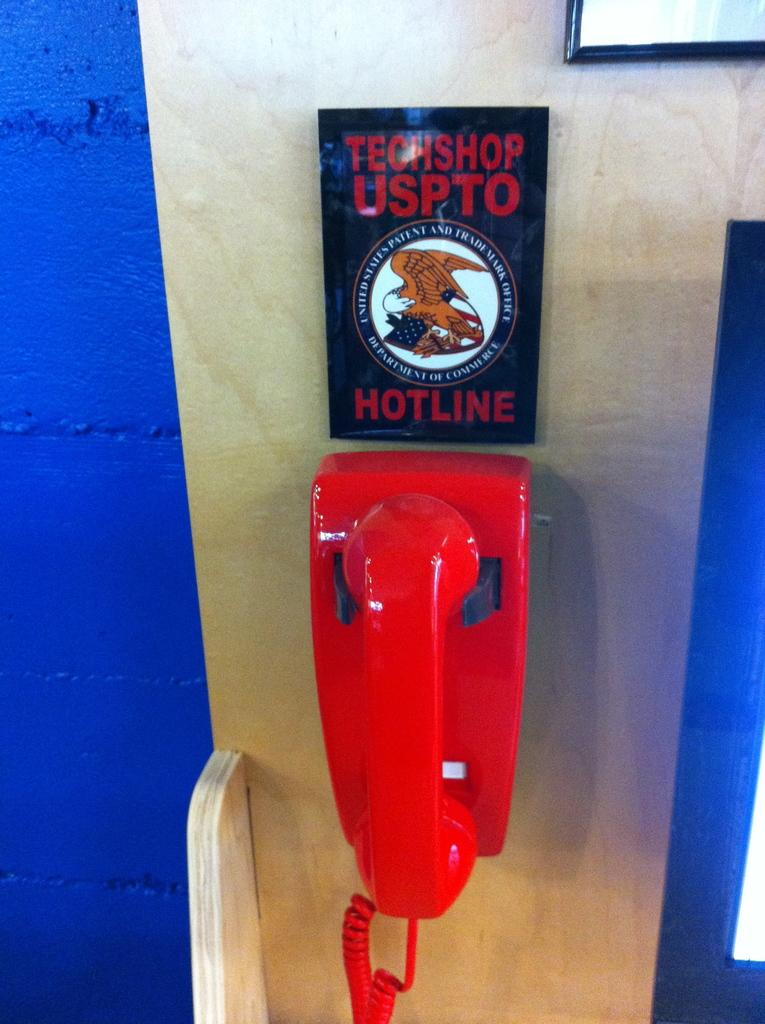<image>
Summarize the visual content of the image. A red wired phone below a sign that says Techshop Uspto Hotline. 